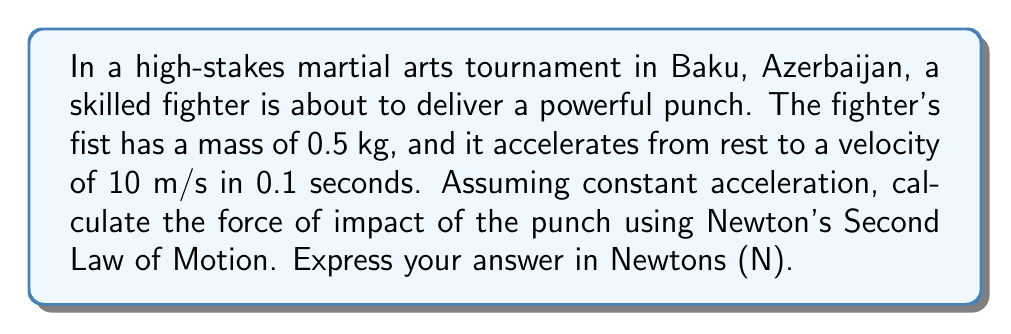Give your solution to this math problem. To solve this problem, we'll use Newton's Second Law of Motion and the equations of motion for constant acceleration. Let's break it down step-by-step:

1) First, we need to calculate the acceleration of the fist. We can use the equation:

   $$v = v_0 + at$$

   Where:
   $v$ is the final velocity (10 m/s)
   $v_0$ is the initial velocity (0 m/s, as it starts from rest)
   $a$ is the acceleration (what we're solving for)
   $t$ is the time (0.1 s)

2) Rearranging the equation to solve for $a$:

   $$a = \frac{v - v_0}{t} = \frac{10 - 0}{0.1} = 100 \text{ m/s}^2$$

3) Now that we have the acceleration, we can use Newton's Second Law:

   $$F = ma$$

   Where:
   $F$ is the force (what we're solving for)
   $m$ is the mass of the fist (0.5 kg)
   $a$ is the acceleration we just calculated (100 m/s²)

4) Plugging in the values:

   $$F = 0.5 \text{ kg} \times 100 \text{ m/s}^2 = 50 \text{ N}$$

Therefore, the force of impact of the punch is 50 Newtons.
Answer: 50 N 